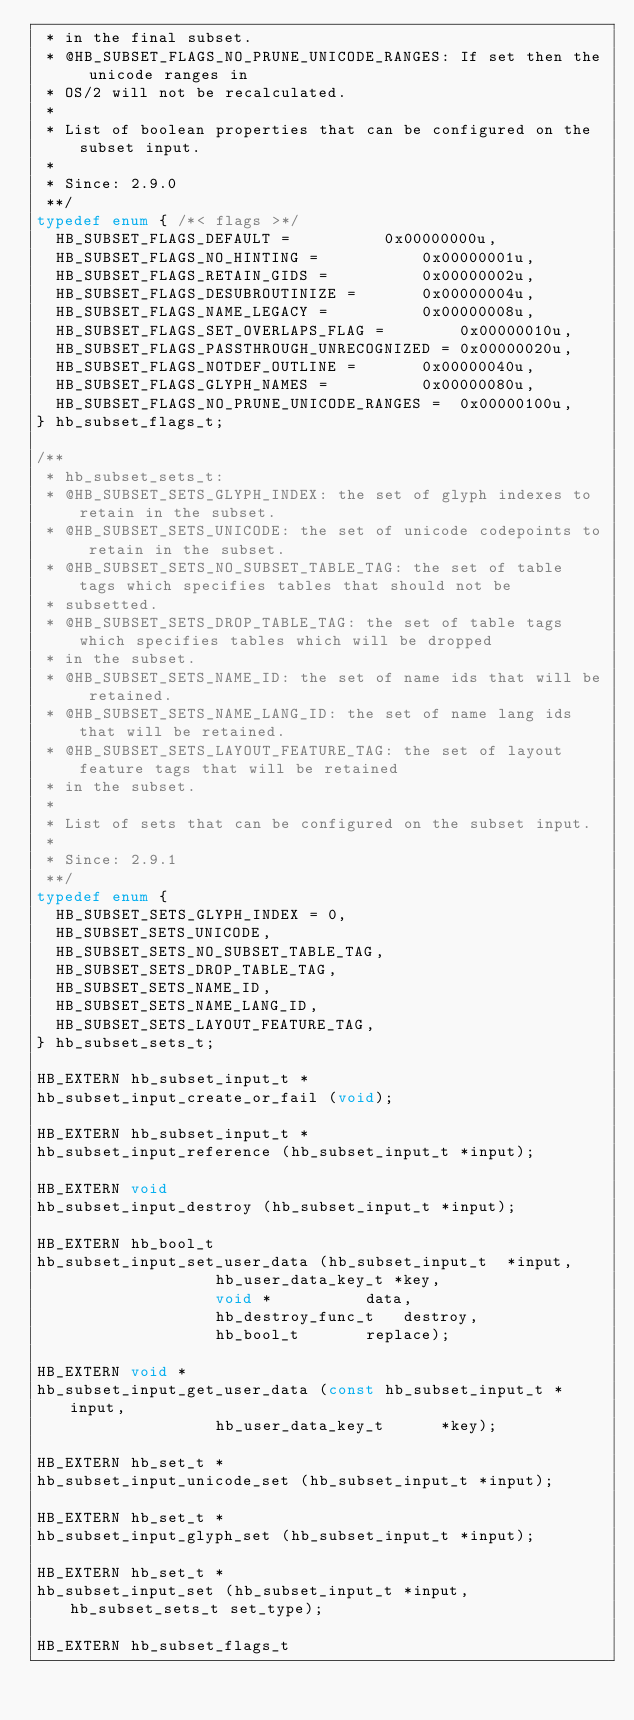<code> <loc_0><loc_0><loc_500><loc_500><_C_> * in the final subset.
 * @HB_SUBSET_FLAGS_NO_PRUNE_UNICODE_RANGES: If set then the unicode ranges in
 * OS/2 will not be recalculated.
 *
 * List of boolean properties that can be configured on the subset input.
 *
 * Since: 2.9.0
 **/
typedef enum { /*< flags >*/
  HB_SUBSET_FLAGS_DEFAULT =		     0x00000000u,
  HB_SUBSET_FLAGS_NO_HINTING =		     0x00000001u,
  HB_SUBSET_FLAGS_RETAIN_GIDS =		     0x00000002u,
  HB_SUBSET_FLAGS_DESUBROUTINIZE =	     0x00000004u,
  HB_SUBSET_FLAGS_NAME_LEGACY =		     0x00000008u,
  HB_SUBSET_FLAGS_SET_OVERLAPS_FLAG =	     0x00000010u,
  HB_SUBSET_FLAGS_PASSTHROUGH_UNRECOGNIZED = 0x00000020u,
  HB_SUBSET_FLAGS_NOTDEF_OUTLINE =	     0x00000040u,
  HB_SUBSET_FLAGS_GLYPH_NAMES =		     0x00000080u,
  HB_SUBSET_FLAGS_NO_PRUNE_UNICODE_RANGES =  0x00000100u,
} hb_subset_flags_t;

/**
 * hb_subset_sets_t:
 * @HB_SUBSET_SETS_GLYPH_INDEX: the set of glyph indexes to retain in the subset.
 * @HB_SUBSET_SETS_UNICODE: the set of unicode codepoints to retain in the subset.
 * @HB_SUBSET_SETS_NO_SUBSET_TABLE_TAG: the set of table tags which specifies tables that should not be
 * subsetted.
 * @HB_SUBSET_SETS_DROP_TABLE_TAG: the set of table tags which specifies tables which will be dropped
 * in the subset.
 * @HB_SUBSET_SETS_NAME_ID: the set of name ids that will be retained.
 * @HB_SUBSET_SETS_NAME_LANG_ID: the set of name lang ids that will be retained.
 * @HB_SUBSET_SETS_LAYOUT_FEATURE_TAG: the set of layout feature tags that will be retained
 * in the subset.
 *
 * List of sets that can be configured on the subset input.
 *
 * Since: 2.9.1
 **/
typedef enum {
  HB_SUBSET_SETS_GLYPH_INDEX = 0,
  HB_SUBSET_SETS_UNICODE,
  HB_SUBSET_SETS_NO_SUBSET_TABLE_TAG,
  HB_SUBSET_SETS_DROP_TABLE_TAG,
  HB_SUBSET_SETS_NAME_ID,
  HB_SUBSET_SETS_NAME_LANG_ID,
  HB_SUBSET_SETS_LAYOUT_FEATURE_TAG,
} hb_subset_sets_t;

HB_EXTERN hb_subset_input_t *
hb_subset_input_create_or_fail (void);

HB_EXTERN hb_subset_input_t *
hb_subset_input_reference (hb_subset_input_t *input);

HB_EXTERN void
hb_subset_input_destroy (hb_subset_input_t *input);

HB_EXTERN hb_bool_t
hb_subset_input_set_user_data (hb_subset_input_t  *input,
			       hb_user_data_key_t *key,
			       void *		   data,
			       hb_destroy_func_t   destroy,
			       hb_bool_t	   replace);

HB_EXTERN void *
hb_subset_input_get_user_data (const hb_subset_input_t *input,
			       hb_user_data_key_t	   *key);

HB_EXTERN hb_set_t *
hb_subset_input_unicode_set (hb_subset_input_t *input);

HB_EXTERN hb_set_t *
hb_subset_input_glyph_set (hb_subset_input_t *input);

HB_EXTERN hb_set_t *
hb_subset_input_set (hb_subset_input_t *input, hb_subset_sets_t set_type);

HB_EXTERN hb_subset_flags_t</code> 